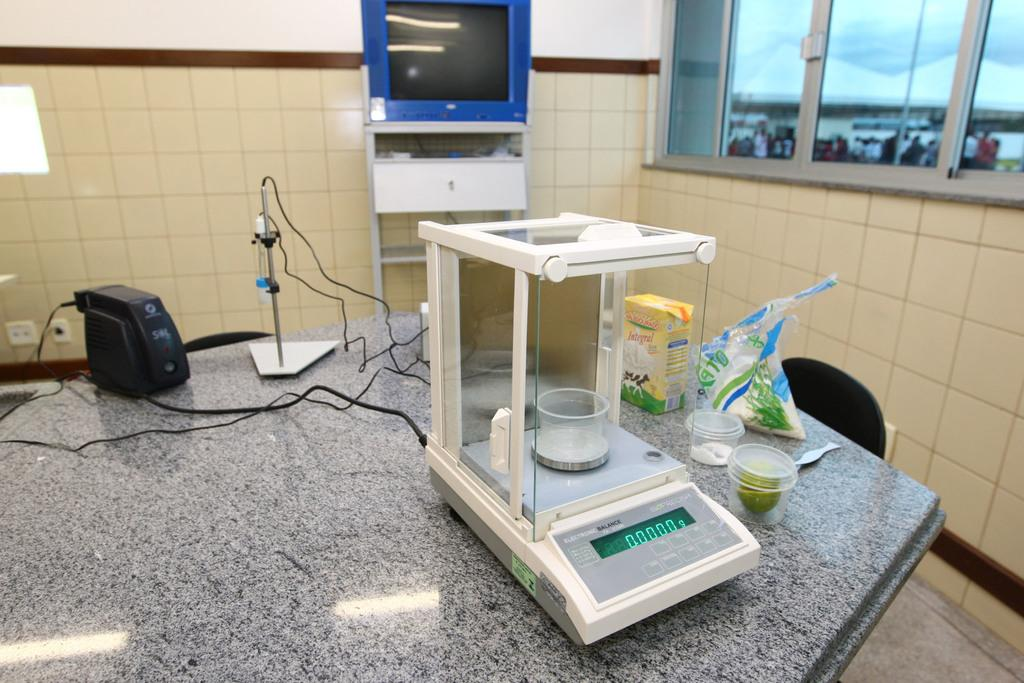<image>
Give a short and clear explanation of the subsequent image. scientific equipment on a marble table including a box of INTEGRAL 